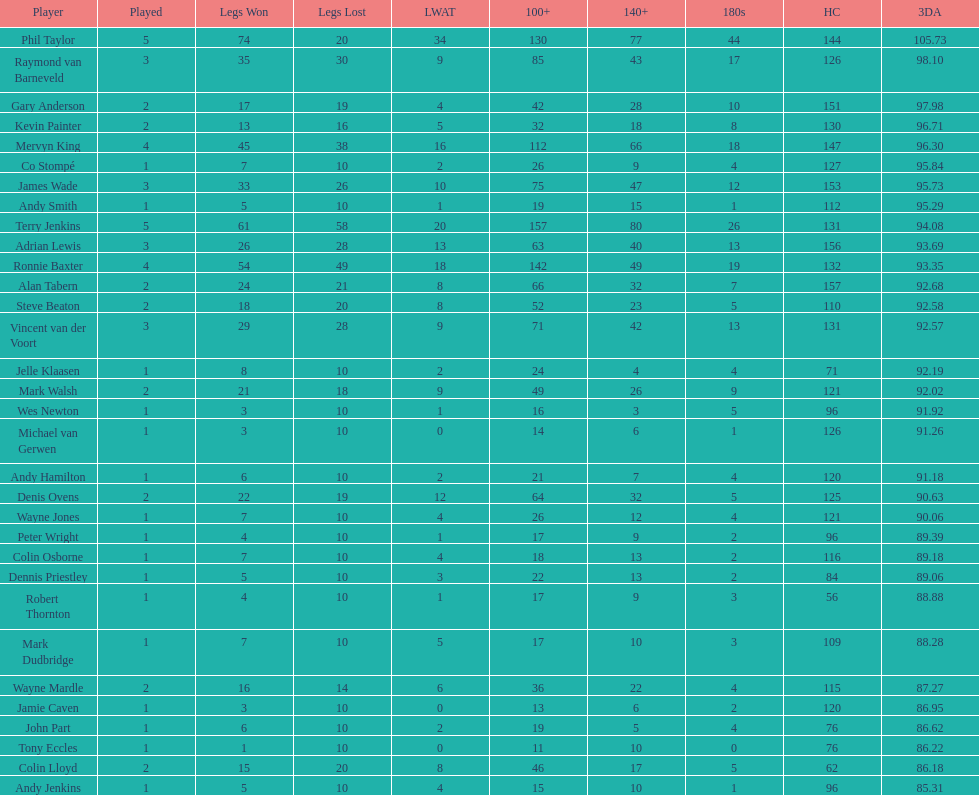Which player had the smallest loss? Co Stompé, Andy Smith, Jelle Klaasen, Wes Newton, Michael van Gerwen, Andy Hamilton, Wayne Jones, Peter Wright, Colin Osborne, Dennis Priestley, Robert Thornton, Mark Dudbridge, Jamie Caven, John Part, Tony Eccles, Andy Jenkins. 